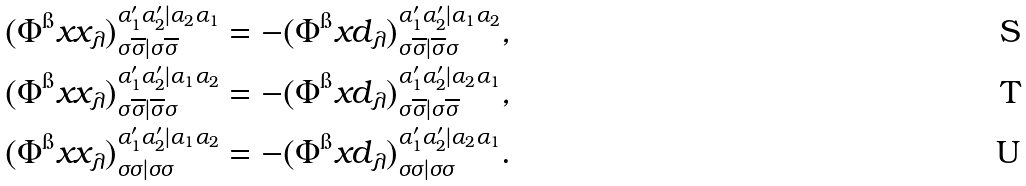Convert formula to latex. <formula><loc_0><loc_0><loc_500><loc_500>( \Phi ^ { \i } x { x } _ { \lambda } ) ^ { \alpha ^ { \prime } _ { 1 } \alpha ^ { \prime } _ { 2 } | \alpha _ { 2 } \alpha _ { 1 } } _ { \sigma \overline { \sigma } | \sigma \overline { \sigma } } & = - ( \Phi ^ { \i } x { d } _ { \lambda } ) ^ { \alpha ^ { \prime } _ { 1 } \alpha ^ { \prime } _ { 2 } | \alpha _ { 1 } \alpha _ { 2 } } _ { \sigma \overline { \sigma } | \overline { \sigma } \sigma } , \\ ( \Phi ^ { \i } x { x } _ { \lambda } ) ^ { \alpha ^ { \prime } _ { 1 } \alpha ^ { \prime } _ { 2 } | \alpha _ { 1 } \alpha _ { 2 } } _ { \sigma \overline { \sigma } | \overline { \sigma } \sigma } & = - ( \Phi ^ { \i } x { d } _ { \lambda } ) ^ { \alpha ^ { \prime } _ { 1 } \alpha ^ { \prime } _ { 2 } | \alpha _ { 2 } \alpha _ { 1 } } _ { \sigma \overline { \sigma } | \sigma \overline { \sigma } } , \\ ( \Phi ^ { \i } x { x } _ { \lambda } ) ^ { \alpha ^ { \prime } _ { 1 } \alpha ^ { \prime } _ { 2 } | \alpha _ { 1 } \alpha _ { 2 } } _ { \sigma \sigma | \sigma \sigma } & = - ( \Phi ^ { \i } x { d } _ { \lambda } ) ^ { \alpha ^ { \prime } _ { 1 } \alpha ^ { \prime } _ { 2 } | \alpha _ { 2 } \alpha _ { 1 } } _ { \sigma \sigma | \sigma \sigma } .</formula> 